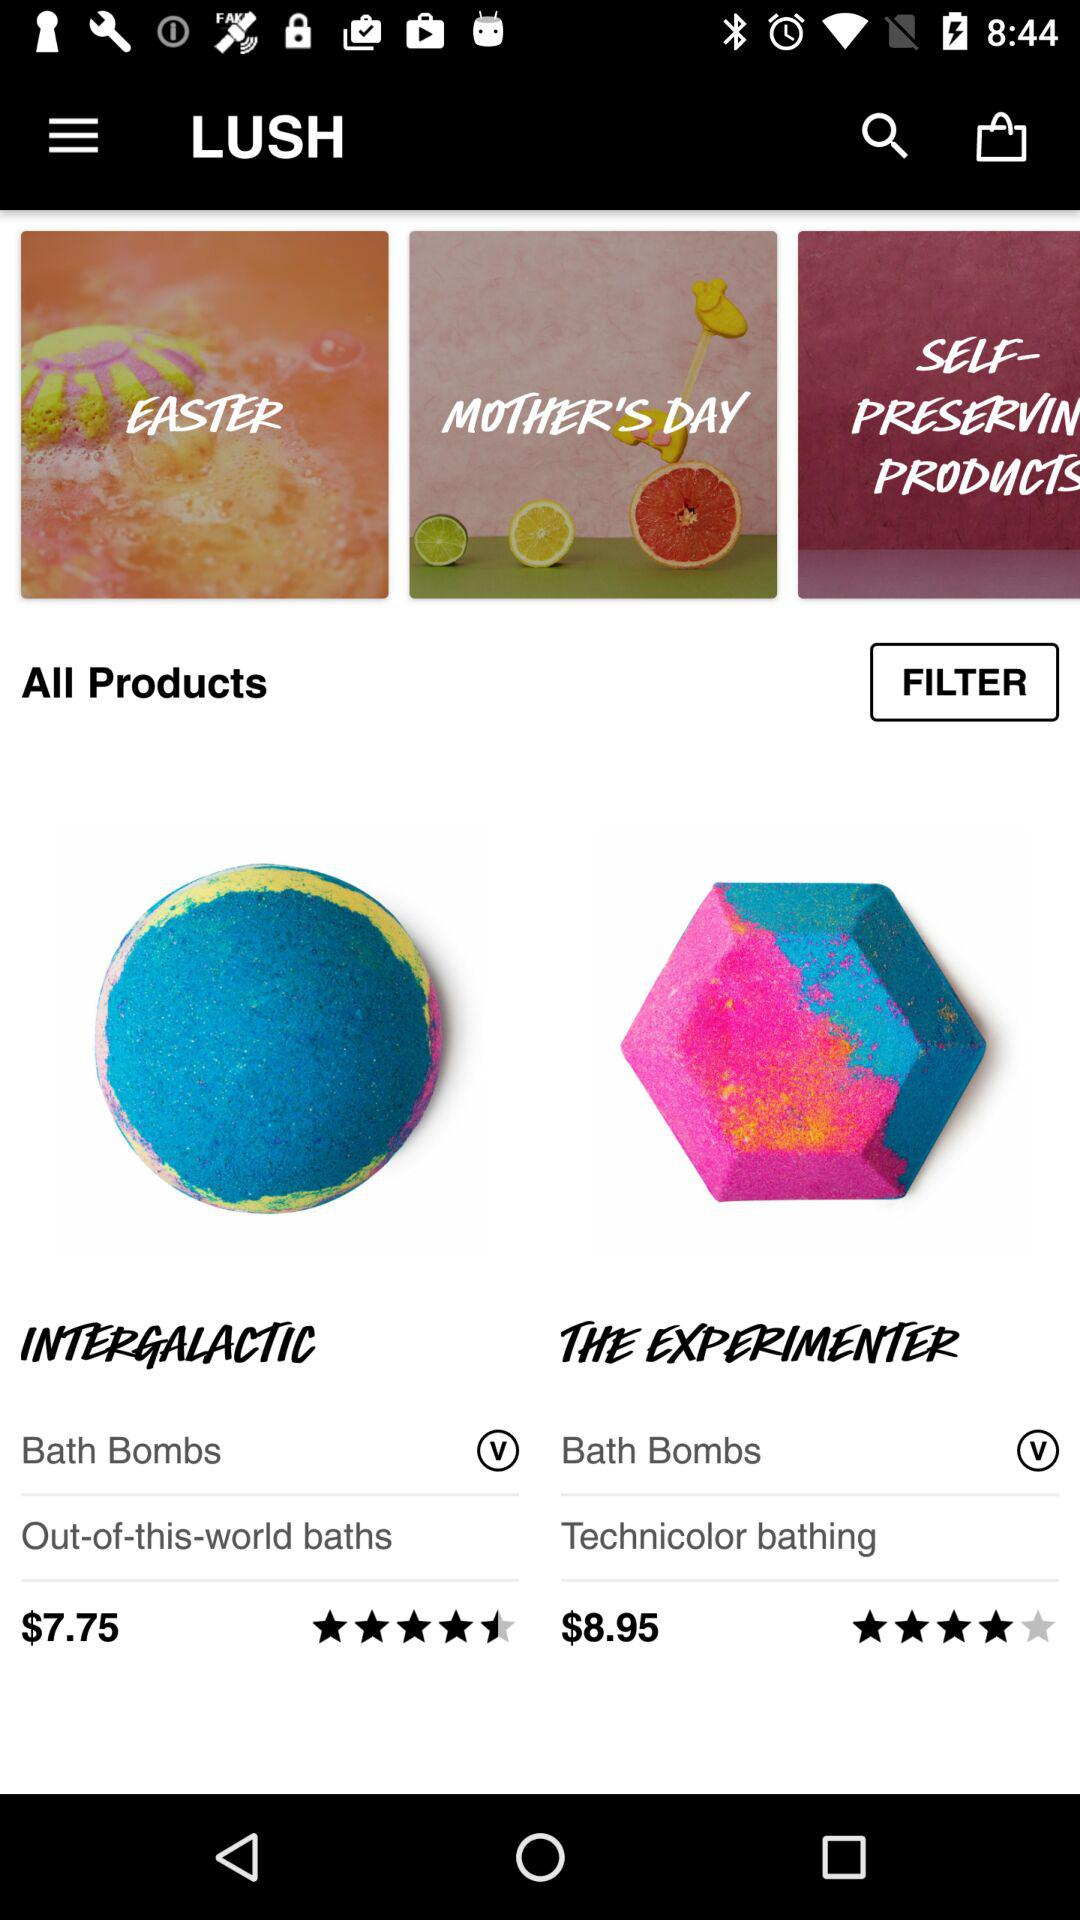What is the price of "THE EXPERIMENTER"? The price of "THE EXPERIMENTER" is $8.95. 